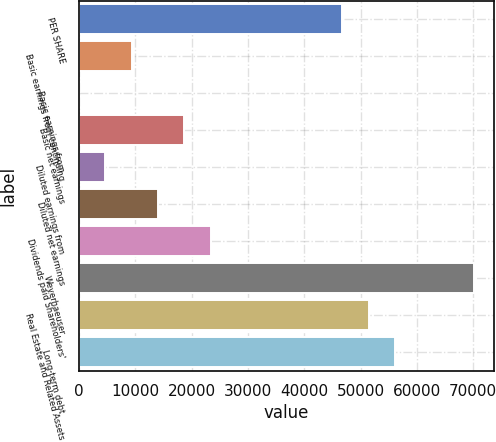Convert chart to OTSL. <chart><loc_0><loc_0><loc_500><loc_500><bar_chart><fcel>PER SHARE<fcel>Basic earnings from continuing<fcel>Basic earnings from<fcel>Basic net earnings<fcel>Diluted earnings from<fcel>Diluted net earnings<fcel>Dividends paid Shareholders'<fcel>Weyerhaeuser<fcel>Real Estate and Related Assets<fcel>Long-term debt<nl><fcel>46737<fcel>9347.72<fcel>0.4<fcel>18695<fcel>4674.06<fcel>14021.4<fcel>23368.7<fcel>70105.3<fcel>51410.7<fcel>56084.3<nl></chart> 